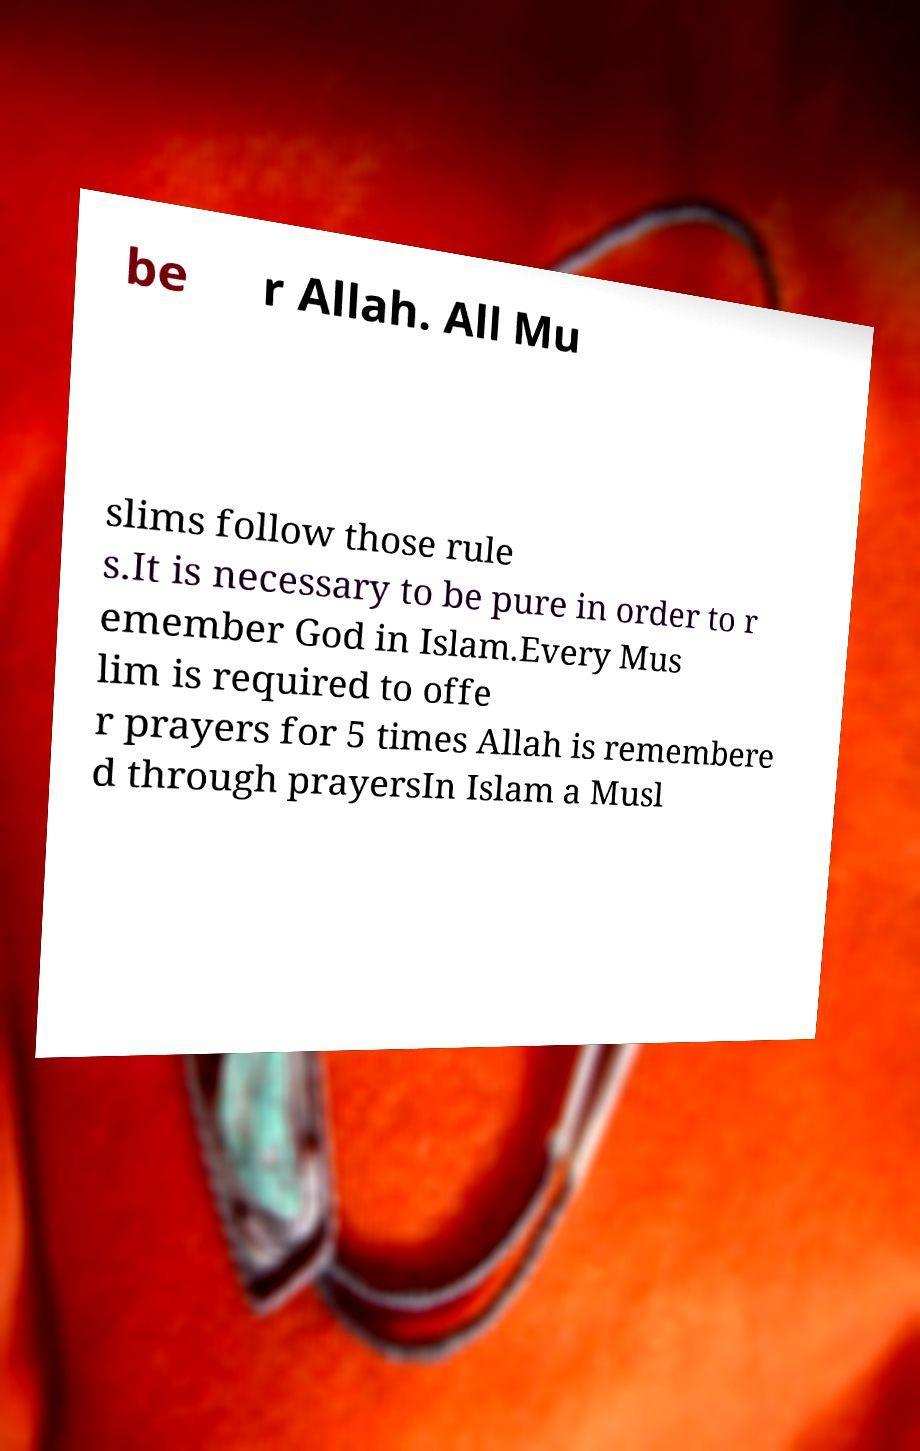For documentation purposes, I need the text within this image transcribed. Could you provide that? be r Allah. All Mu slims follow those rule s.It is necessary to be pure in order to r emember God in Islam.Every Mus lim is required to offe r prayers for 5 times Allah is remembere d through prayersIn Islam a Musl 